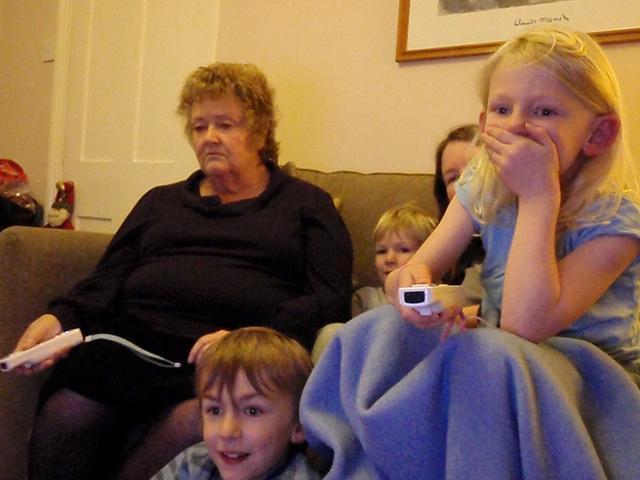How many people are visible?
Give a very brief answer. 4. How many trucks are there?
Give a very brief answer. 0. 